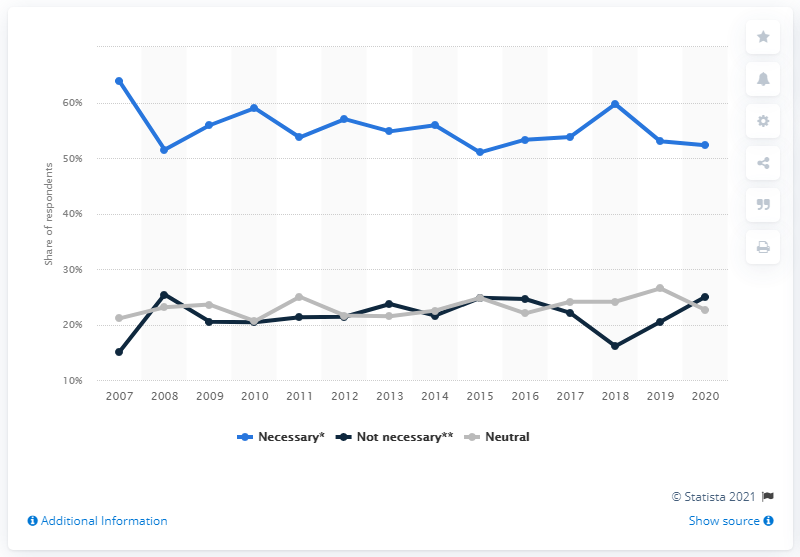Identify some key points in this picture. A survey was conducted in South Korea in the year 2020. 